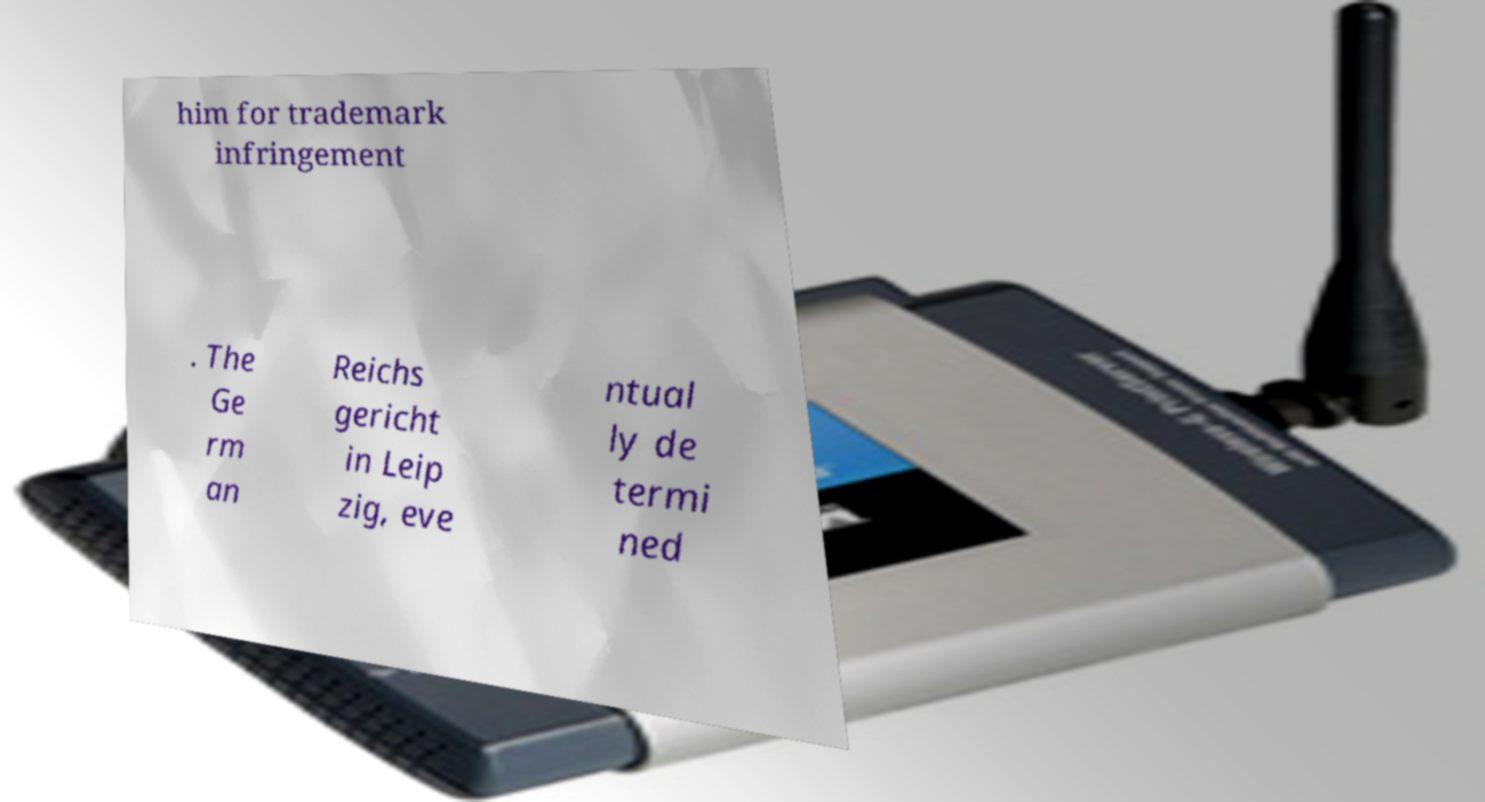Can you accurately transcribe the text from the provided image for me? him for trademark infringement . The Ge rm an Reichs gericht in Leip zig, eve ntual ly de termi ned 